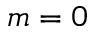<formula> <loc_0><loc_0><loc_500><loc_500>m = 0</formula> 